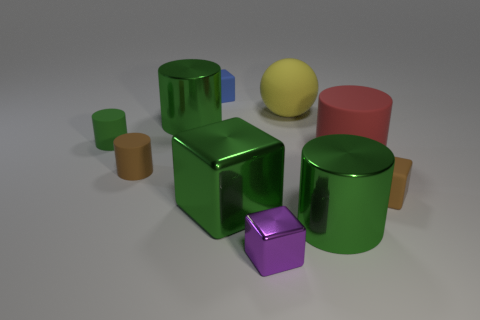Is there anything else that is the same shape as the big yellow rubber thing?
Your answer should be very brief. No. There is a cylinder that is to the left of the small purple metal cube and right of the small brown cylinder; what is its material?
Your answer should be compact. Metal. Do the tiny purple object and the large cylinder that is left of the small blue rubber cube have the same material?
Your answer should be very brief. Yes. How many things are either big yellow rubber things or matte things that are on the right side of the large matte cylinder?
Provide a succinct answer. 2. There is a rubber cube behind the small green matte cylinder; is its size the same as the green metal cylinder that is to the right of the large yellow matte thing?
Offer a very short reply. No. How many other objects are the same color as the sphere?
Keep it short and to the point. 0. There is a yellow matte ball; does it have the same size as the brown rubber thing left of the yellow matte sphere?
Your answer should be very brief. No. What is the size of the green shiny cylinder in front of the cube that is right of the big red cylinder?
Ensure brevity in your answer.  Large. What color is the small metallic thing that is the same shape as the blue rubber object?
Offer a terse response. Purple. Is the green matte thing the same size as the blue object?
Provide a succinct answer. Yes. 